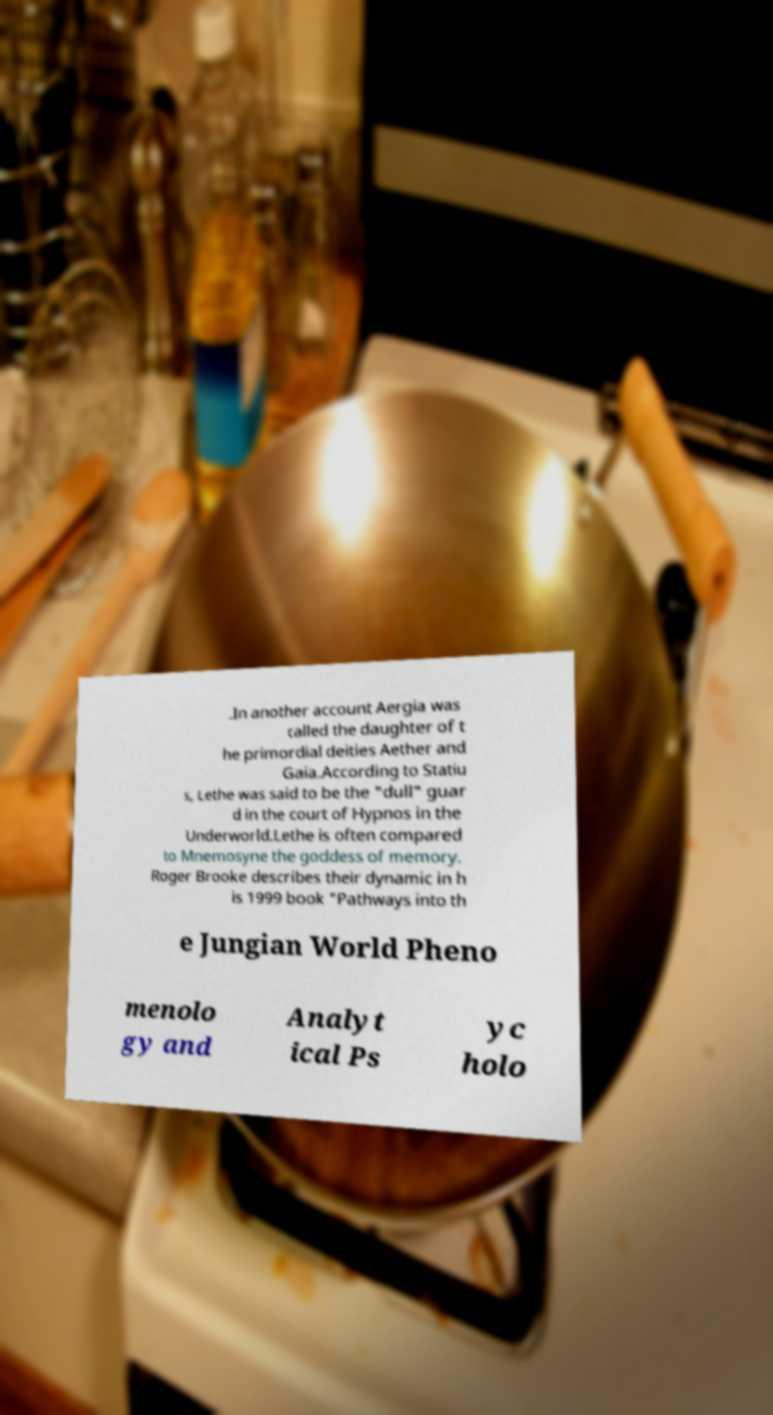For documentation purposes, I need the text within this image transcribed. Could you provide that? .In another account Aergia was called the daughter of t he primordial deities Aether and Gaia.According to Statiu s, Lethe was said to be the "dull" guar d in the court of Hypnos in the Underworld.Lethe is often compared to Mnemosyne the goddess of memory. Roger Brooke describes their dynamic in h is 1999 book "Pathways into th e Jungian World Pheno menolo gy and Analyt ical Ps yc holo 